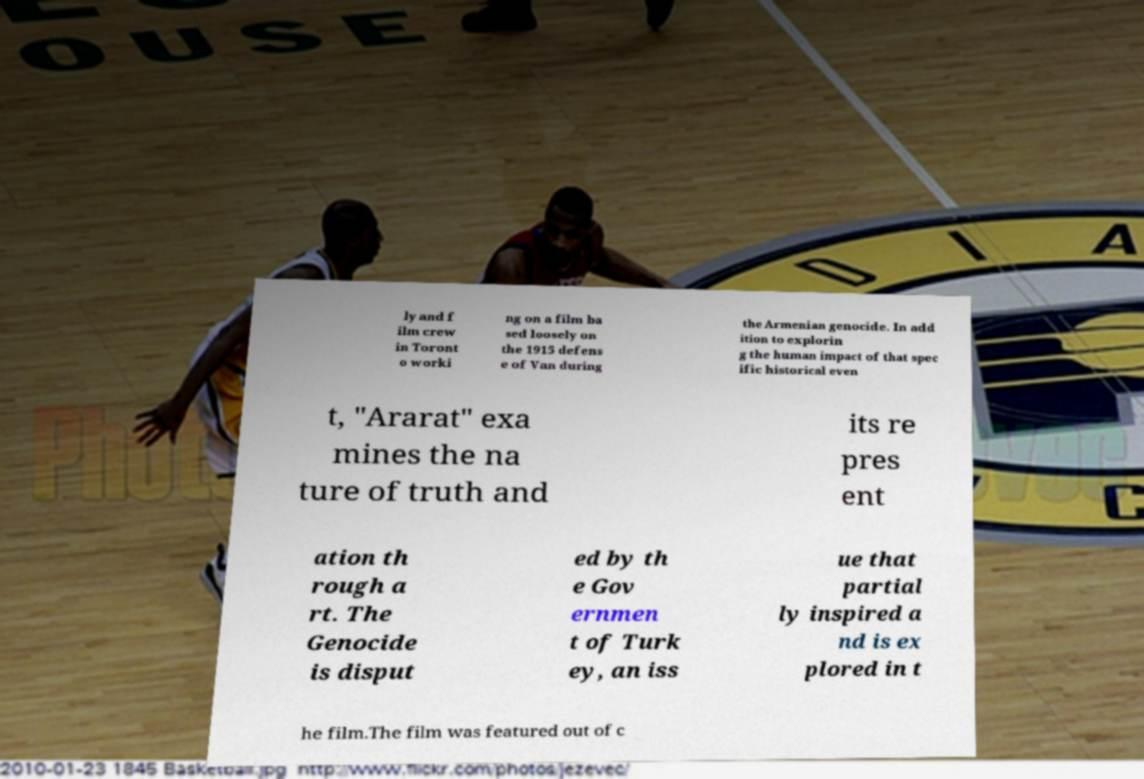Can you read and provide the text displayed in the image?This photo seems to have some interesting text. Can you extract and type it out for me? ly and f ilm crew in Toront o worki ng on a film ba sed loosely on the 1915 defens e of Van during the Armenian genocide. In add ition to explorin g the human impact of that spec ific historical even t, "Ararat" exa mines the na ture of truth and its re pres ent ation th rough a rt. The Genocide is disput ed by th e Gov ernmen t of Turk ey, an iss ue that partial ly inspired a nd is ex plored in t he film.The film was featured out of c 